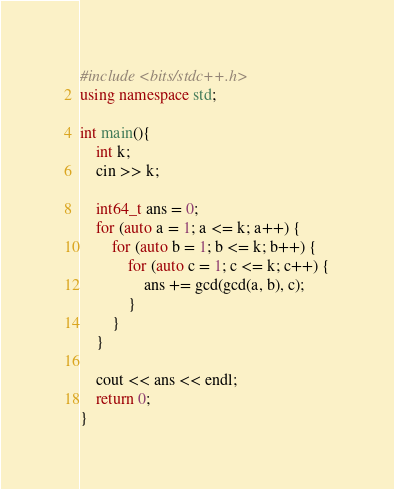Convert code to text. <code><loc_0><loc_0><loc_500><loc_500><_C++_>#include <bits/stdc++.h>
using namespace std;

int main(){
    int k;
    cin >> k;

    int64_t ans = 0;
    for (auto a = 1; a <= k; a++) {
        for (auto b = 1; b <= k; b++) {
            for (auto c = 1; c <= k; c++) {
                ans += gcd(gcd(a, b), c);
            }
        }
    }

    cout << ans << endl;
    return 0;
}</code> 